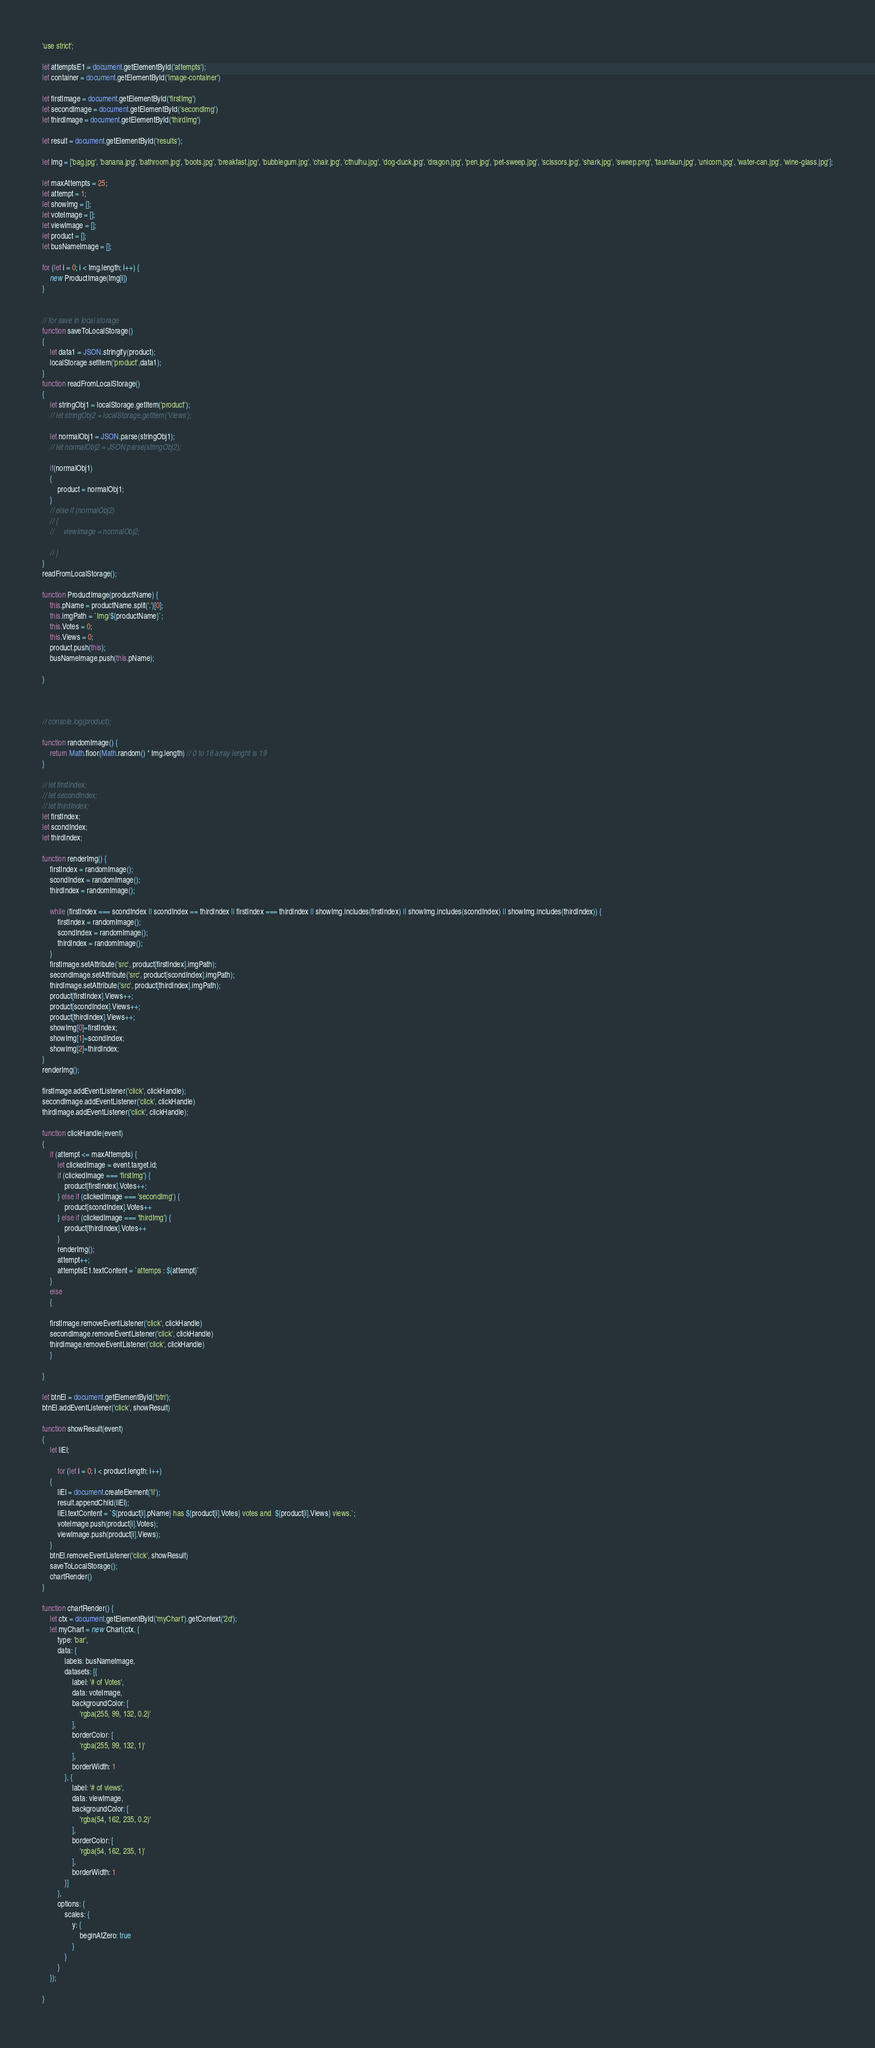Convert code to text. <code><loc_0><loc_0><loc_500><loc_500><_JavaScript_>'use strict';

let attemptsE1 = document.getElementById('attempts');
let container = document.getElementById('image-container')

let firstImage = document.getElementById('firstImg')
let secondImage = document.getElementById('secondImg')
let thirdImage = document.getElementById('thirdImg')

let result = document.getElementById('results');

let Img = ['bag.jpg', 'banana.jpg', 'bathroom.jpg', 'boots.jpg', 'breakfast.jpg', 'bubblegum.jpg', 'chair.jpg', 'cthulhu.jpg', 'dog-duck.jpg', 'dragon.jpg', 'pen.jpg', 'pet-sweep.jpg', 'scissors.jpg', 'shark.jpg', 'sweep.png', 'tauntaun.jpg', 'unicorn.jpg', 'water-can.jpg', 'wine-glass.jpg'];

let maxAttempts = 25;
let attempt = 1;
let showImg = [];
let voteImage = [];
let viewImage = [];
let product = [];
let busNameImage = [];

for (let i = 0; i < Img.length; i++) {
    new ProductImage(Img[i])
}


// for save in local storage
function saveToLocalStorage()
{
    let data1 = JSON.stringify(product);
    localStorage.setItem('product',data1);
}
function readFromLocalStorage()
{
    let stringObj1 = localStorage.getItem('product');
    // let stringObj2 = localStorage.getItem('Views');
    
    let normalObj1 = JSON.parse(stringObj1);
    // let normalObj2 = JSON.parse(stringObj2);

    if(normalObj1)
    {  
        product = normalObj1;
    }
    // else if (normalObj2)
    // {
    //     viewImage = normalObj2;

    // }
}
readFromLocalStorage();

function ProductImage(productName) {
    this.pName = productName.split('.')[0];
    this.imgPath = `Img/${productName}`;
    this.Votes = 0;
    this.Views = 0;
    product.push(this);
    busNameImage.push(this.pName);

}



// console.log(product);

function randomImage() {
    return Math.floor(Math.random() * Img.length) // 0 to 18 array lenght is 19
}

// let firstIndex;
// let secondIndex;
// let thirdIndex;
let firstIndex;
let scondIndex;
let thirdIndex;

function renderImg() {
    firstIndex = randomImage();
    scondIndex = randomImage();
    thirdIndex = randomImage();

    while (firstIndex === scondIndex || scondIndex == thirdIndex || firstIndex === thirdIndex || showImg.includes(firstIndex) || showImg.includes(scondIndex) || showImg.includes(thirdIndex)) {
        firstIndex = randomImage();
        scondIndex = randomImage();
        thirdIndex = randomImage();
    }
    firstImage.setAttribute('src', product[firstIndex].imgPath);
    secondImage.setAttribute('src', product[scondIndex].imgPath);
    thirdImage.setAttribute('src', product[thirdIndex].imgPath);
    product[firstIndex].Views++;
    product[scondIndex].Views++;
    product[thirdIndex].Views++;
    showImg[0]=firstIndex;
    showImg[1]=scondIndex;
    showImg[2]=thirdIndex;
}
renderImg();

firstImage.addEventListener('click', clickHandle);
secondImage.addEventListener('click', clickHandle)
thirdImage.addEventListener('click', clickHandle);

function clickHandle(event) 
{
    if (attempt <= maxAttempts) {
        let clickedImage = event.target.id;
        if (clickedImage === 'firstImg') {
            product[firstIndex].Votes++;
        } else if (clickedImage === 'secondImg') {
            product[scondIndex].Votes++
        } else if (clickedImage === 'thirdImg') {
            product[thirdIndex].Votes++
        }
        renderImg();
        attempt++;
        attemptsE1.textContent = `attemps : ${attempt}`
    }
    else
    {
    
    firstImage.removeEventListener('click', clickHandle)
    secondImage.removeEventListener('click', clickHandle)
    thirdImage.removeEventListener('click', clickHandle)
    }

}

let btnEl = document.getElementById('btn');
btnEl.addEventListener('click', showResult)

function showResult(event) 
{
    let liEl;
    
        for (let i = 0; i < product.length; i++) 
    {
        liEl = document.createElement('li');
        result.appendChild(liEl);
        liEl.textContent = `${product[i].pName} has ${product[i].Votes} votes and  ${product[i].Views} views.`;
        voteImage.push(product[i].Votes);
        viewImage.push(product[i].Views);
    }
    btnEl.removeEventListener('click', showResult)
    saveToLocalStorage();
    chartRender()
}

function chartRender() {
    let ctx = document.getElementById('myChart').getContext('2d');
    let myChart = new Chart(ctx, {
        type: 'bar',
        data: {
            labels: busNameImage,
            datasets: [{
                label: '# of Votes',
                data: voteImage,
                backgroundColor: [
                    'rgba(255, 99, 132, 0.2)'
                ],
                borderColor: [
                    'rgba(255, 99, 132, 1)'
                ],
                borderWidth: 1
            }, {
                label: '# of views',
                data: viewImage,
                backgroundColor: [
                    'rgba(54, 162, 235, 0.2)'
                ],
                borderColor: [
                    'rgba(54, 162, 235, 1)'
                ],
                borderWidth: 1
            }]
        },
        options: {
            scales: {
                y: {
                    beginAtZero: true
                }
            }
        }
    });
    
}</code> 